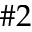<formula> <loc_0><loc_0><loc_500><loc_500>\# 2</formula> 